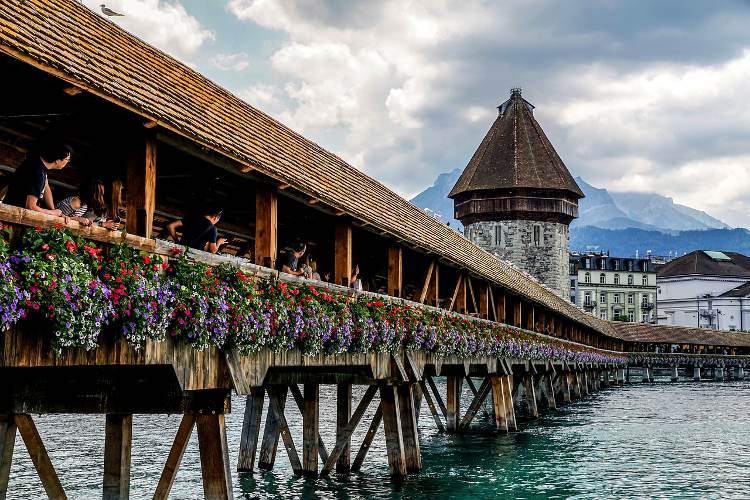What is the historical significance of the Chapel Bridge? The Chapel Bridge, or Kapellbrücke, constructed in the early 14th century, is historically significant primarily because it was built for the fortification of Lucerne. Part of its uniqueness lies in the interior paintings dating back to the 17th century, which depict scenes from Lucerne's history, although many were destroyed in a fire in 1993. Its continued preservation makes it a key historical site and a symbol of Lucerne's medieval heritage. 